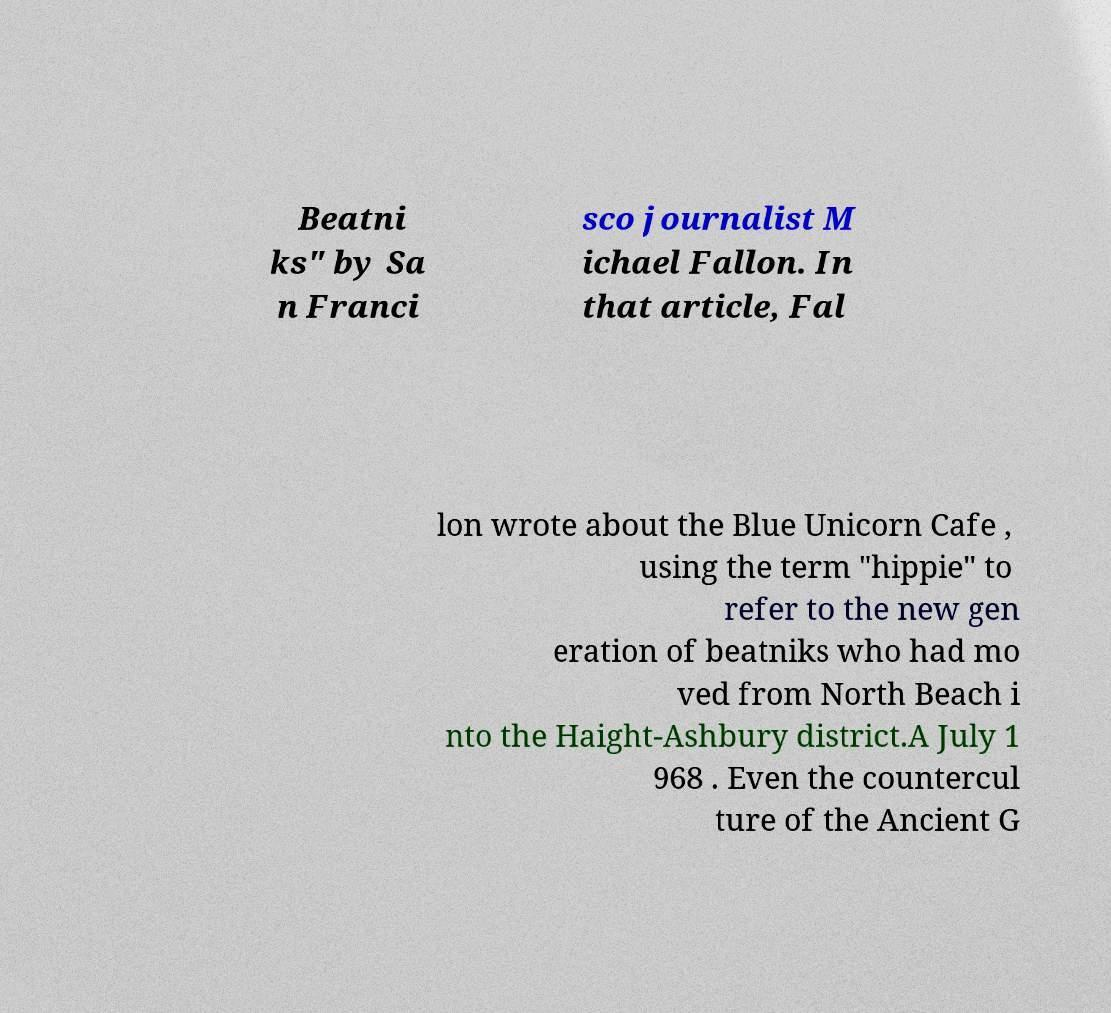Could you extract and type out the text from this image? Beatni ks" by Sa n Franci sco journalist M ichael Fallon. In that article, Fal lon wrote about the Blue Unicorn Cafe , using the term "hippie" to refer to the new gen eration of beatniks who had mo ved from North Beach i nto the Haight-Ashbury district.A July 1 968 . Even the countercul ture of the Ancient G 